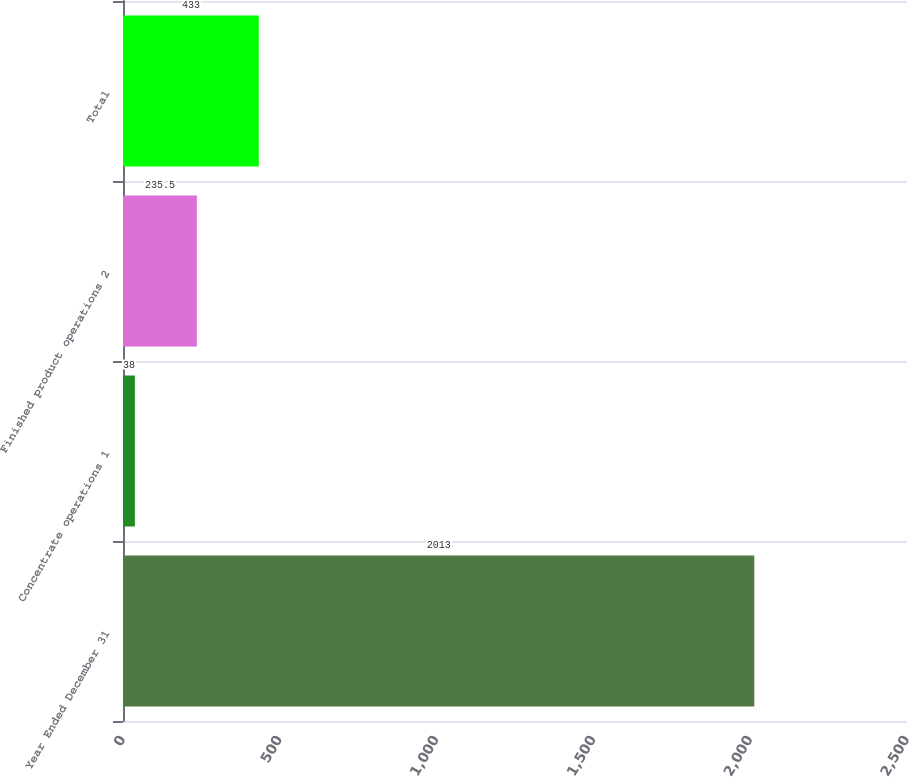Convert chart to OTSL. <chart><loc_0><loc_0><loc_500><loc_500><bar_chart><fcel>Year Ended December 31<fcel>Concentrate operations 1<fcel>Finished product operations 2<fcel>Total<nl><fcel>2013<fcel>38<fcel>235.5<fcel>433<nl></chart> 